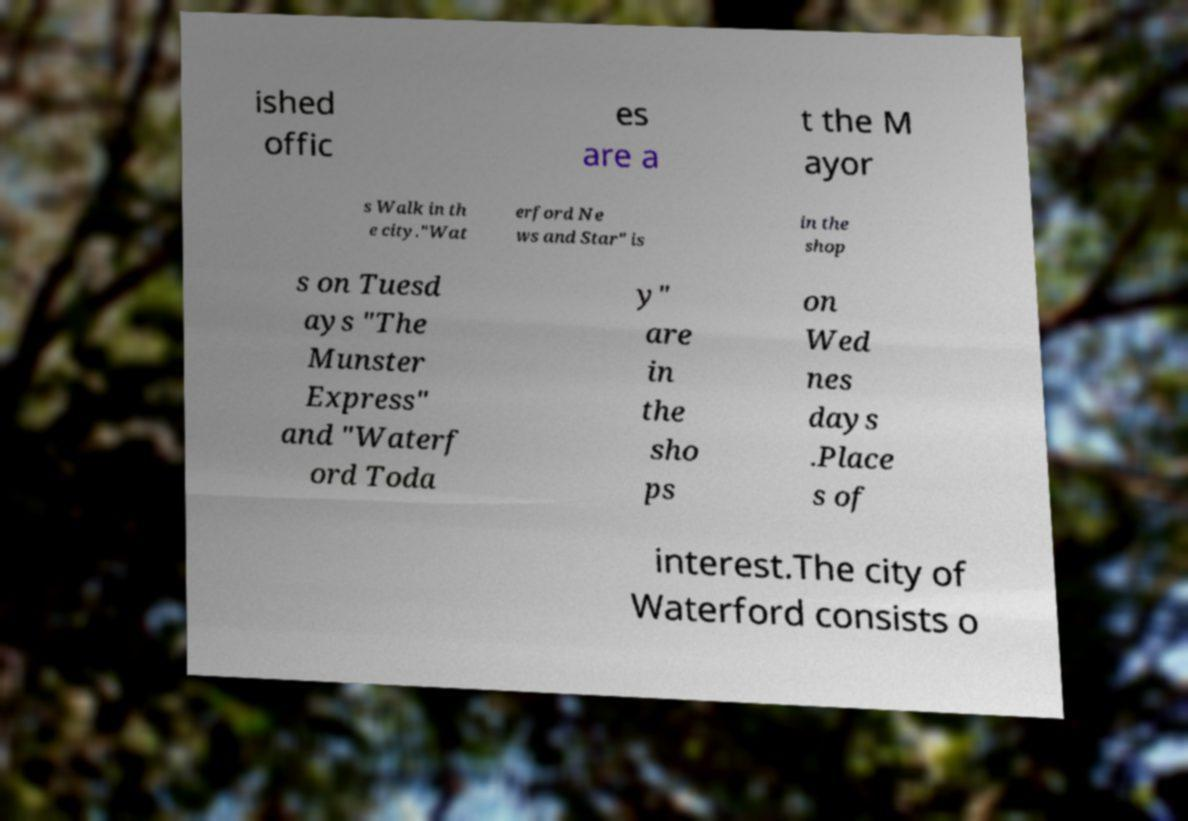Please identify and transcribe the text found in this image. ished offic es are a t the M ayor s Walk in th e city."Wat erford Ne ws and Star" is in the shop s on Tuesd ays "The Munster Express" and "Waterf ord Toda y" are in the sho ps on Wed nes days .Place s of interest.The city of Waterford consists o 